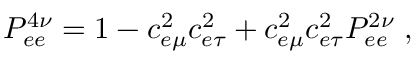<formula> <loc_0><loc_0><loc_500><loc_500>P _ { e e } ^ { 4 \nu } = 1 - c _ { e \mu } ^ { 2 } c _ { e \tau } ^ { 2 } + c _ { e \mu } ^ { 2 } c _ { e \tau } ^ { 2 } P _ { e e } ^ { 2 \nu } \, ,</formula> 